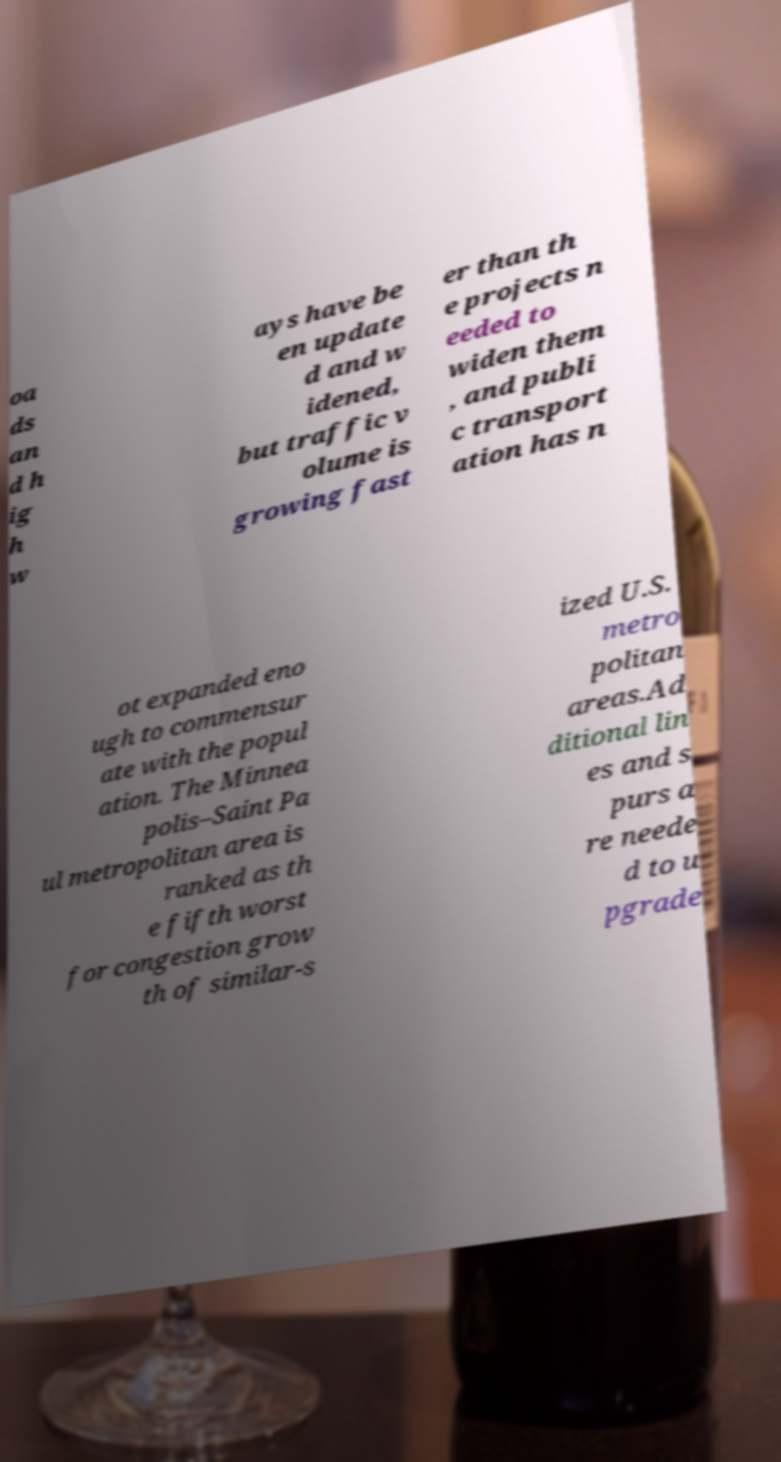Can you accurately transcribe the text from the provided image for me? oa ds an d h ig h w ays have be en update d and w idened, but traffic v olume is growing fast er than th e projects n eeded to widen them , and publi c transport ation has n ot expanded eno ugh to commensur ate with the popul ation. The Minnea polis–Saint Pa ul metropolitan area is ranked as th e fifth worst for congestion grow th of similar-s ized U.S. metro politan areas.Ad ditional lin es and s purs a re neede d to u pgrade 